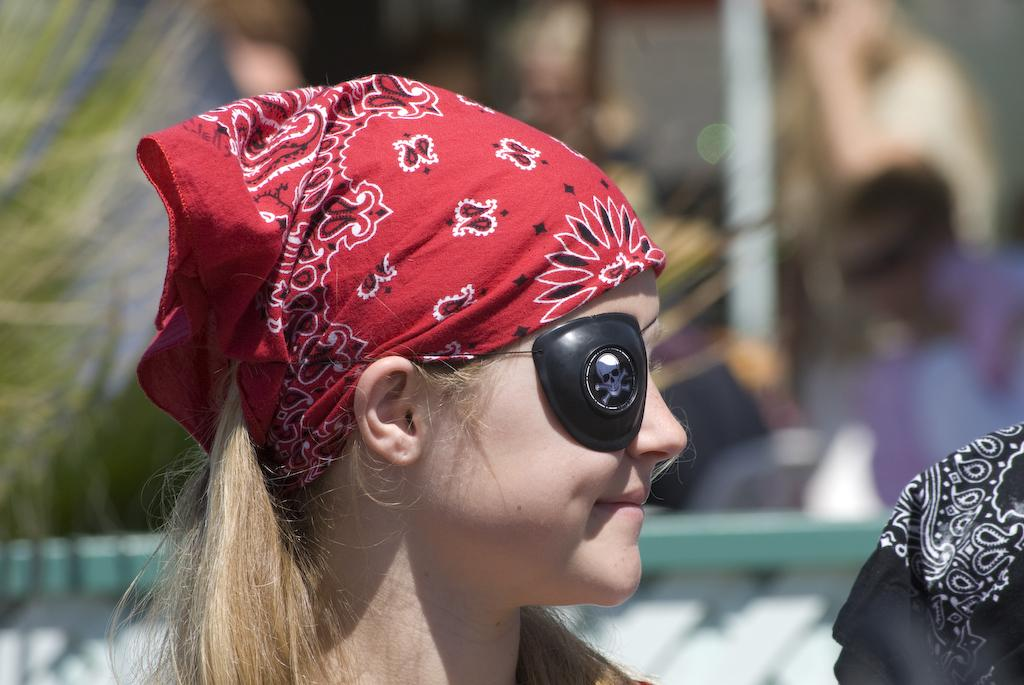What is the main subject of the image? The main subject of the image is a kid. What is the kid wearing on her head? The kid is wearing red cloth on her head. What is the kid doing with one of her eyes? The kid has an object on one of her eyes. What is the kid's facial expression? The kid is smiling. What can be seen in the background of the image? There are other objects in the background of the image. What type of jar is the kid holding in the image? There is no jar present in the image. What book is the kid reading in the image? There is no book or reading activity depicted in the image. 